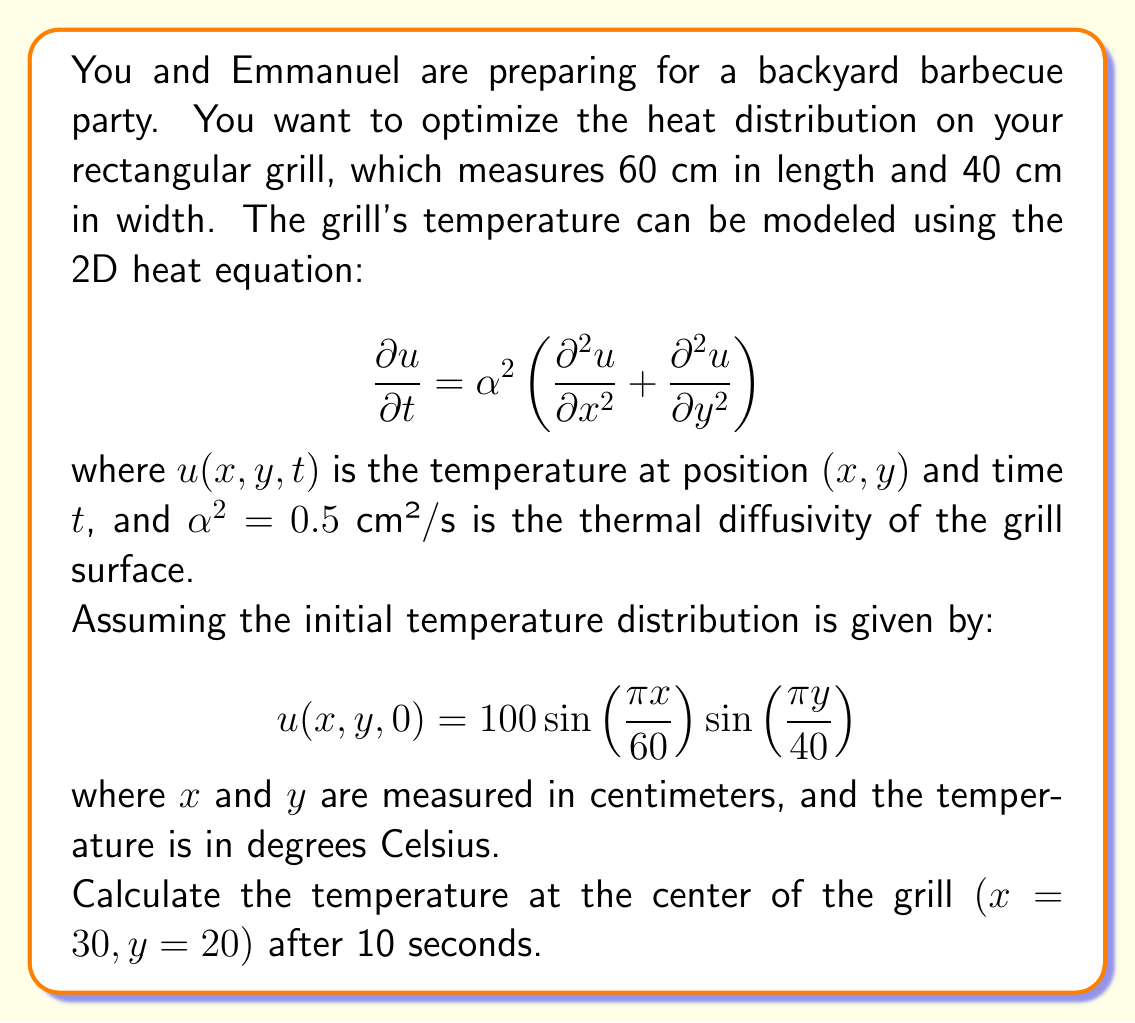Solve this math problem. To solve this problem, we need to use the separation of variables method for the 2D heat equation. The solution will have the form:

$$u(x,y,t) = X(x)Y(y)T(t)$$

Given the initial condition, we can see that the spatial components are:

$$X(x) = \sin\left(\frac{\pi x}{60}\right)$$
$$Y(y) = \sin\left(\frac{\pi y}{40}\right)$$

Now, we need to find the time component $T(t)$. Substituting the solution form into the heat equation:

$$X(x)Y(y)T'(t) = \alpha^2 \left(X''(x)Y(y)T(t) + X(x)Y''(y)T(t)\right)$$

Dividing both sides by $X(x)Y(y)T(t)$:

$$\frac{T'(t)}{T(t)} = \alpha^2 \left(\frac{X''(x)}{X(x)} + \frac{Y''(y)}{Y(y)}\right) = -\lambda^2$$

Where $\lambda^2$ is a constant. This gives us:

$$T(t) = e^{-\lambda^2 \alpha^2 t}$$

For the spatial components:

$$\frac{X''(x)}{X(x)} = -\left(\frac{\pi}{60}\right)^2$$
$$\frac{Y''(y)}{Y(y)} = -\left(\frac{\pi}{40}\right)^2$$

Therefore:

$$\lambda^2 = \left(\frac{\pi}{60}\right)^2 + \left(\frac{\pi}{40}\right)^2$$

The complete solution is:

$$u(x,y,t) = 100 \sin\left(\frac{\pi x}{60}\right) \sin\left(\frac{\pi y}{40}\right) e^{-\alpha^2 \left(\left(\frac{\pi}{60}\right)^2 + \left(\frac{\pi}{40}\right)^2\right) t}$$

Now, we can calculate the temperature at the center of the grill $(x=30, y=20)$ after 10 seconds:

$$u(30,20,10) = 100 \sin\left(\frac{\pi \cdot 30}{60}\right) \sin\left(\frac{\pi \cdot 20}{40}\right) e^{-0.5 \left(\left(\frac{\pi}{60}\right)^2 + \left(\frac{\pi}{40}\right)^2\right) 10}$$

$$= 100 \cdot 1 \cdot 1 \cdot e^{-0.5 \left(\frac{\pi^2}{3600} + \frac{\pi^2}{1600}\right) 10}$$

$$= 100 e^{-0.5 \cdot \frac{5\pi^2}{3600} \cdot 10}$$

$$\approx 70.97 \text{ °C}$$
Answer: The temperature at the center of the grill $(x=30, y=20)$ after 10 seconds is approximately 70.97 °C. 